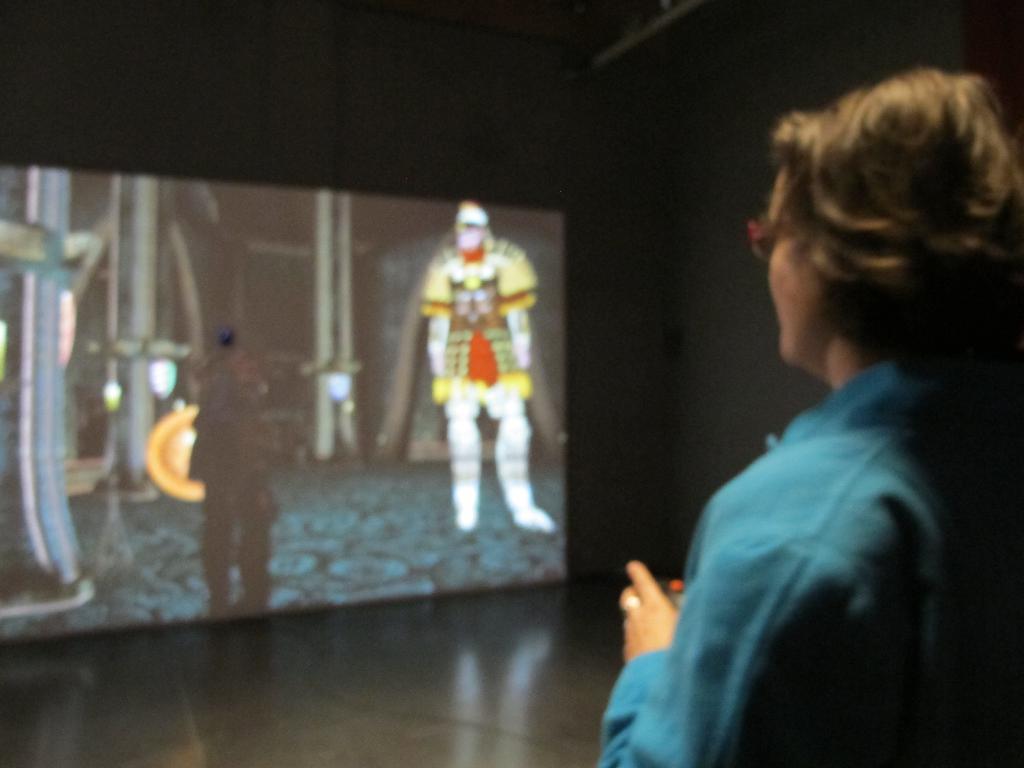Could you give a brief overview of what you see in this image? Here on the right side we can see a woman standing on the floor and in front of her we can see a digital screen present and something cartoon is running on the screen over there. 